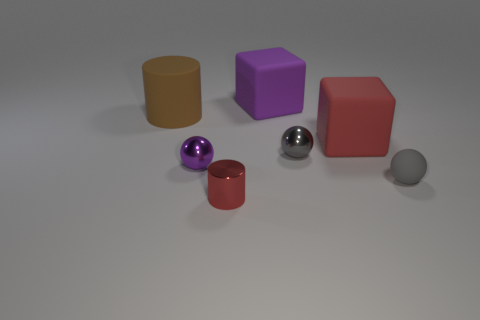Subtract all gray rubber balls. How many balls are left? 2 Subtract all gray balls. How many balls are left? 1 Subtract all red blocks. How many gray balls are left? 2 Subtract 1 balls. How many balls are left? 2 Add 1 small spheres. How many objects exist? 8 Subtract all cylinders. How many objects are left? 5 Subtract all cyan cylinders. Subtract all yellow cubes. How many cylinders are left? 2 Add 4 gray matte objects. How many gray matte objects exist? 5 Subtract 0 yellow spheres. How many objects are left? 7 Subtract all gray spheres. Subtract all purple metal objects. How many objects are left? 4 